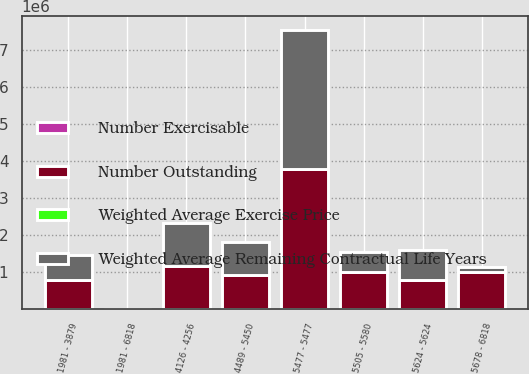<chart> <loc_0><loc_0><loc_500><loc_500><stacked_bar_chart><ecel><fcel>1981 - 3879<fcel>4126 - 4256<fcel>4489 - 5450<fcel>5477 - 5477<fcel>5505 - 5580<fcel>5624 - 5624<fcel>5678 - 6818<fcel>1981 - 6818<nl><fcel>Number Outstanding<fcel>773809<fcel>1.16071e+06<fcel>919008<fcel>3.77143e+06<fcel>989156<fcel>791942<fcel>987862<fcel>60.18<nl><fcel>Number Exercisable<fcel>4.04<fcel>3.58<fcel>5.54<fcel>4.22<fcel>4.81<fcel>6.51<fcel>6.41<fcel>4.74<nl><fcel>Weighted Average Exercise Price<fcel>35.81<fcel>41.26<fcel>45.35<fcel>54.77<fcel>55.49<fcel>56.24<fcel>64.12<fcel>51.8<nl><fcel>Weighted Average Remaining Contractual Life Years<fcel>687500<fcel>1.1592e+06<fcel>902443<fcel>3.77143e+06<fcel>550848<fcel>788361<fcel>144062<fcel>60.18<nl></chart> 